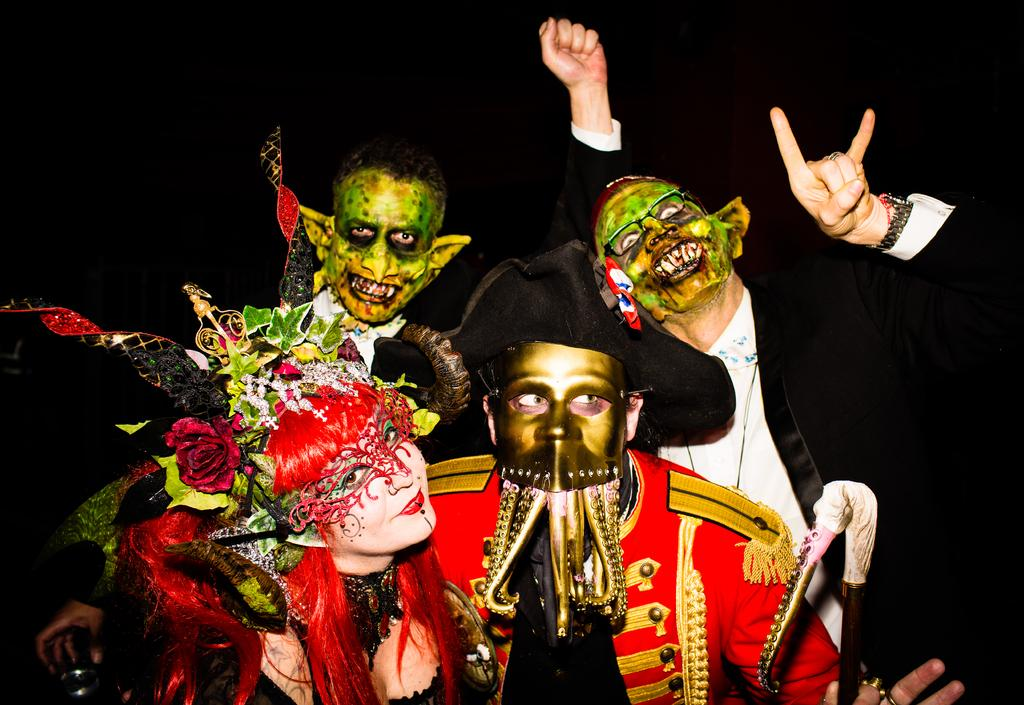How many people are in the image? There are four persons in the image. What are the four persons wearing? The four persons are wearing costumes. What type of sponge is being used to give advice to the campers in the image? There is no sponge, advice, or campers present in the image. 